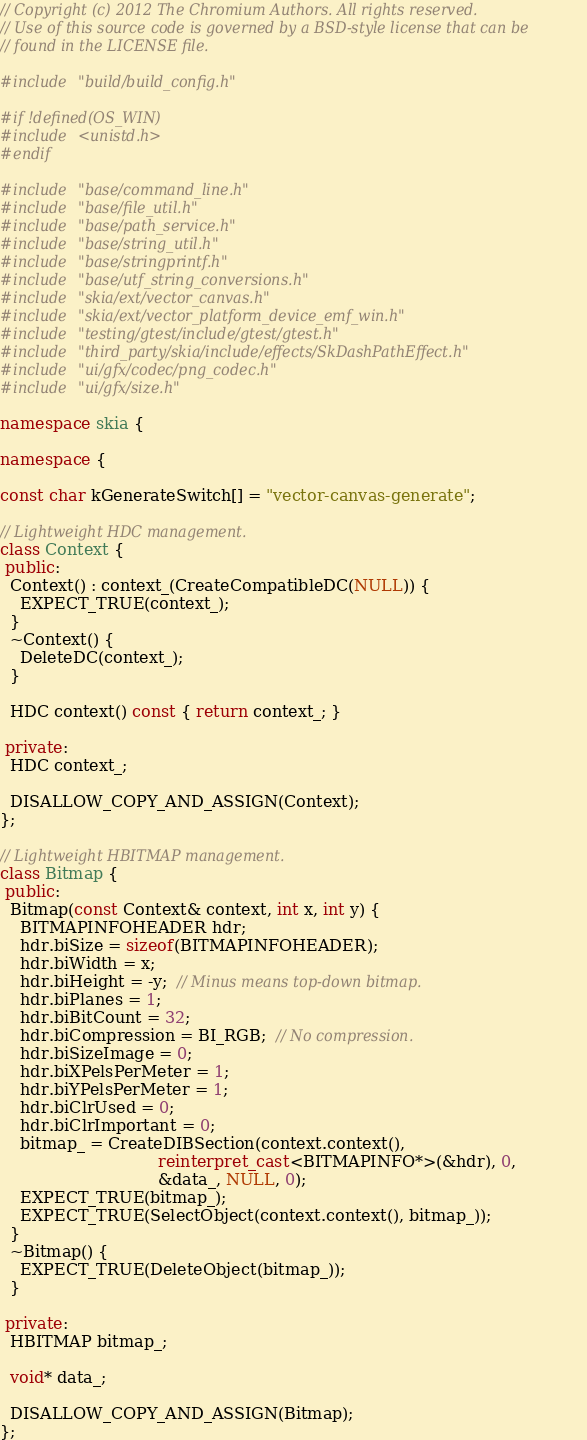Convert code to text. <code><loc_0><loc_0><loc_500><loc_500><_C++_>// Copyright (c) 2012 The Chromium Authors. All rights reserved.
// Use of this source code is governed by a BSD-style license that can be
// found in the LICENSE file.

#include "build/build_config.h"

#if !defined(OS_WIN)
#include <unistd.h>
#endif

#include "base/command_line.h"
#include "base/file_util.h"
#include "base/path_service.h"
#include "base/string_util.h"
#include "base/stringprintf.h"
#include "base/utf_string_conversions.h"
#include "skia/ext/vector_canvas.h"
#include "skia/ext/vector_platform_device_emf_win.h"
#include "testing/gtest/include/gtest/gtest.h"
#include "third_party/skia/include/effects/SkDashPathEffect.h"
#include "ui/gfx/codec/png_codec.h"
#include "ui/gfx/size.h"

namespace skia {

namespace {

const char kGenerateSwitch[] = "vector-canvas-generate";

// Lightweight HDC management.
class Context {
 public:
  Context() : context_(CreateCompatibleDC(NULL)) {
    EXPECT_TRUE(context_);
  }
  ~Context() {
    DeleteDC(context_);
  }

  HDC context() const { return context_; }

 private:
  HDC context_;

  DISALLOW_COPY_AND_ASSIGN(Context);
};

// Lightweight HBITMAP management.
class Bitmap {
 public:
  Bitmap(const Context& context, int x, int y) {
    BITMAPINFOHEADER hdr;
    hdr.biSize = sizeof(BITMAPINFOHEADER);
    hdr.biWidth = x;
    hdr.biHeight = -y;  // Minus means top-down bitmap.
    hdr.biPlanes = 1;
    hdr.biBitCount = 32;
    hdr.biCompression = BI_RGB;  // No compression.
    hdr.biSizeImage = 0;
    hdr.biXPelsPerMeter = 1;
    hdr.biYPelsPerMeter = 1;
    hdr.biClrUsed = 0;
    hdr.biClrImportant = 0;
    bitmap_ = CreateDIBSection(context.context(),
                               reinterpret_cast<BITMAPINFO*>(&hdr), 0,
                               &data_, NULL, 0);
    EXPECT_TRUE(bitmap_);
    EXPECT_TRUE(SelectObject(context.context(), bitmap_));
  }
  ~Bitmap() {
    EXPECT_TRUE(DeleteObject(bitmap_));
  }

 private:
  HBITMAP bitmap_;

  void* data_;

  DISALLOW_COPY_AND_ASSIGN(Bitmap);
};
</code> 